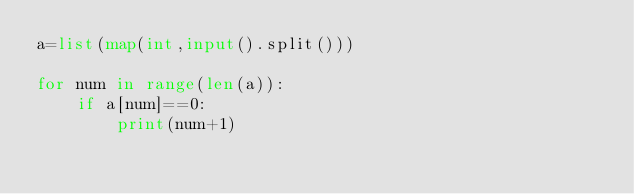Convert code to text. <code><loc_0><loc_0><loc_500><loc_500><_Python_>a=list(map(int,input().split()))

for num in range(len(a)):
    if a[num]==0:
        print(num+1)</code> 